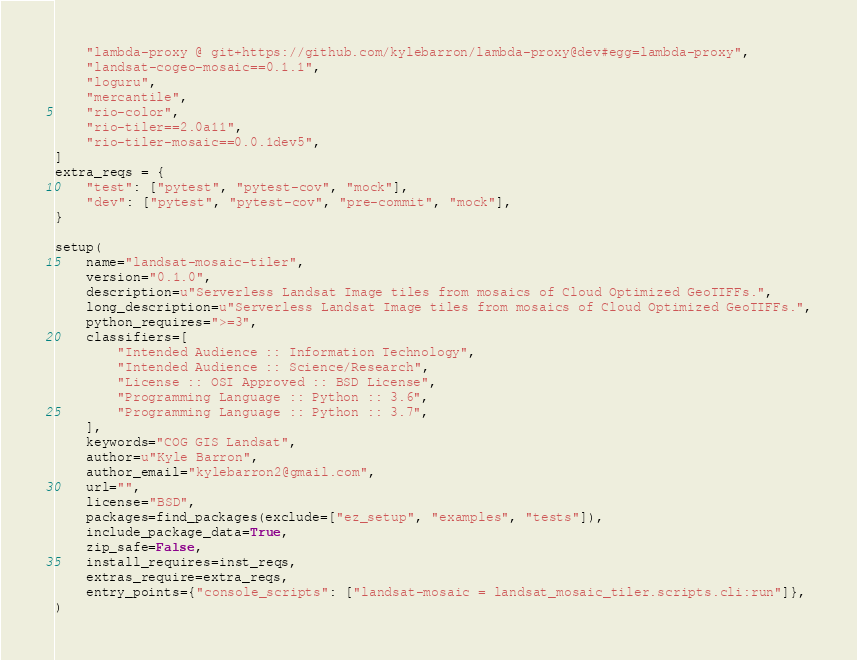<code> <loc_0><loc_0><loc_500><loc_500><_Python_>    "lambda-proxy @ git+https://github.com/kylebarron/lambda-proxy@dev#egg=lambda-proxy",
    "landsat-cogeo-mosaic==0.1.1",
    "loguru",
    "mercantile",
    "rio-color",
    "rio-tiler==2.0a11",
    "rio-tiler-mosaic==0.0.1dev5",
]
extra_reqs = {
    "test": ["pytest", "pytest-cov", "mock"],
    "dev": ["pytest", "pytest-cov", "pre-commit", "mock"],
}

setup(
    name="landsat-mosaic-tiler",
    version="0.1.0",
    description=u"Serverless Landsat Image tiles from mosaics of Cloud Optimized GeoTIFFs.",
    long_description=u"Serverless Landsat Image tiles from mosaics of Cloud Optimized GeoTIFFs.",
    python_requires=">=3",
    classifiers=[
        "Intended Audience :: Information Technology",
        "Intended Audience :: Science/Research",
        "License :: OSI Approved :: BSD License",
        "Programming Language :: Python :: 3.6",
        "Programming Language :: Python :: 3.7",
    ],
    keywords="COG GIS Landsat",
    author=u"Kyle Barron",
    author_email="kylebarron2@gmail.com",
    url="",
    license="BSD",
    packages=find_packages(exclude=["ez_setup", "examples", "tests"]),
    include_package_data=True,
    zip_safe=False,
    install_requires=inst_reqs,
    extras_require=extra_reqs,
    entry_points={"console_scripts": ["landsat-mosaic = landsat_mosaic_tiler.scripts.cli:run"]},
)
</code> 